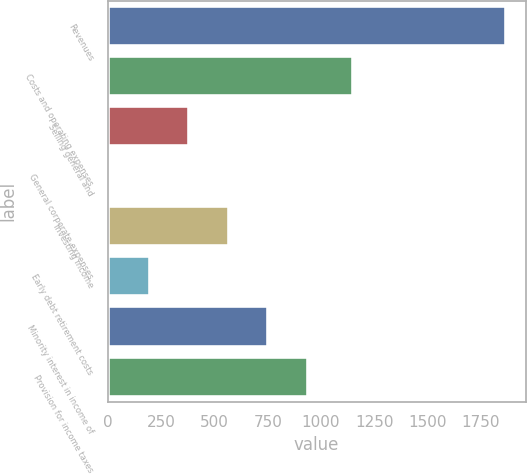<chart> <loc_0><loc_0><loc_500><loc_500><bar_chart><fcel>Revenues<fcel>Costs and operating expenses<fcel>Selling general and<fcel>General corporate expenses<fcel>Investing income<fcel>Early debt retirement costs<fcel>Minority interest in income of<fcel>Provision for income taxes<nl><fcel>1866<fcel>1149<fcel>382.8<fcel>12<fcel>568.2<fcel>197.4<fcel>753.6<fcel>939<nl></chart> 